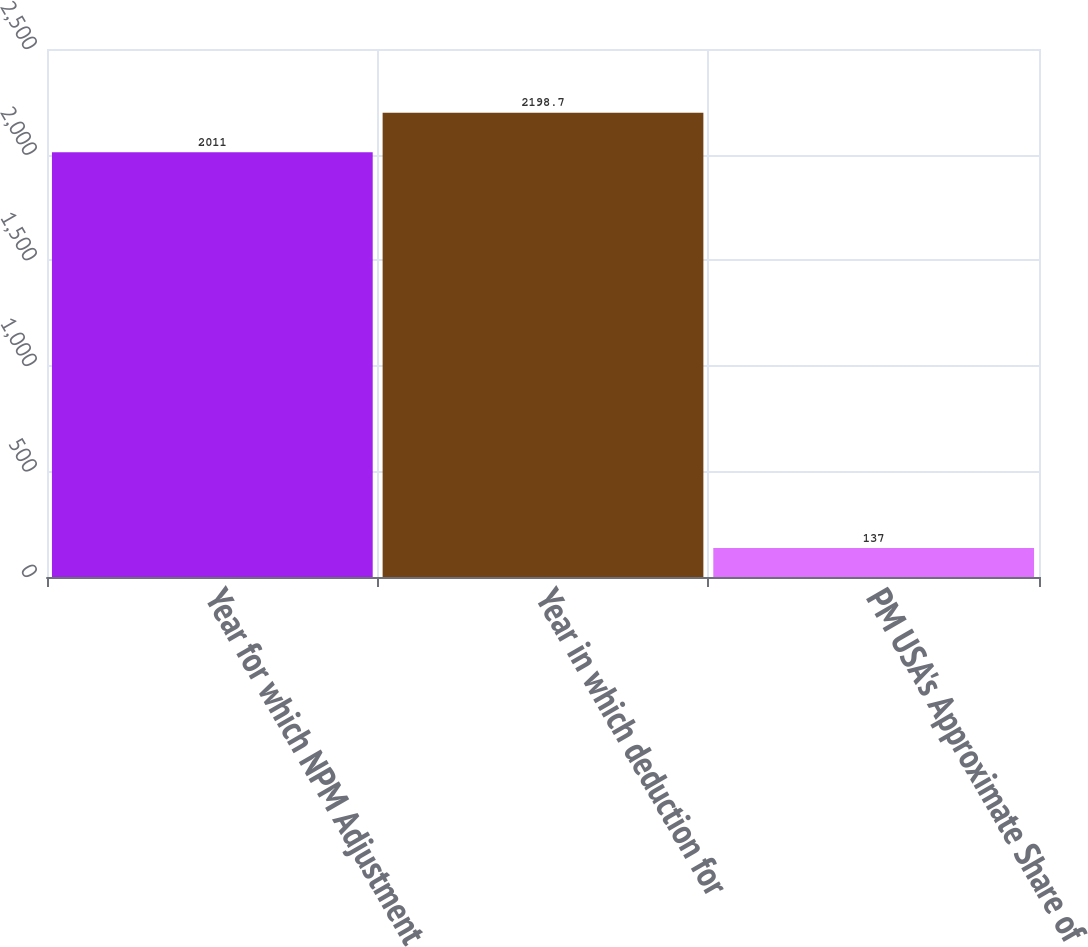Convert chart. <chart><loc_0><loc_0><loc_500><loc_500><bar_chart><fcel>Year for which NPM Adjustment<fcel>Year in which deduction for<fcel>PM USA's Approximate Share of<nl><fcel>2011<fcel>2198.7<fcel>137<nl></chart> 